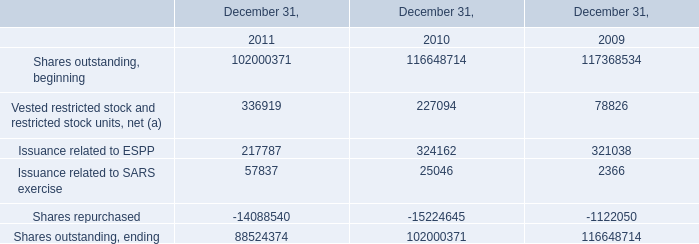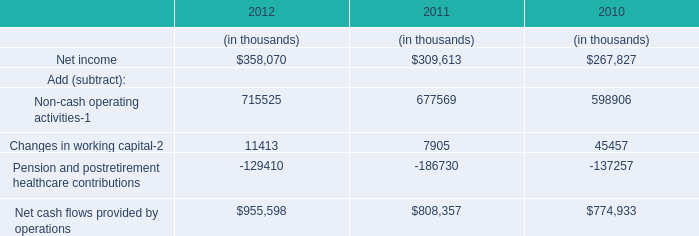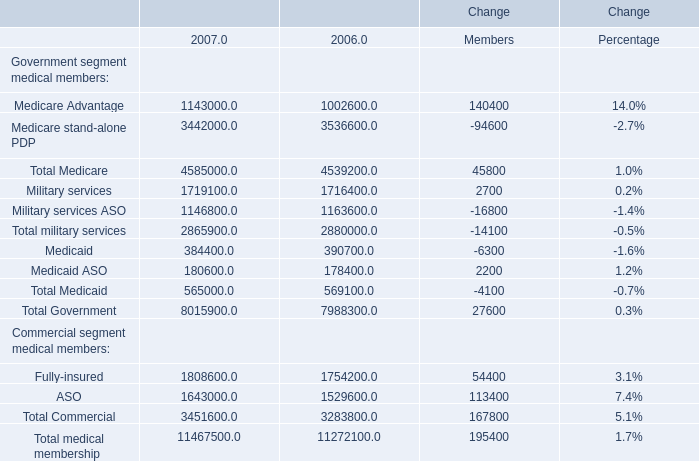When is the amount of Total medical membership larger? 
Answer: 2007. 